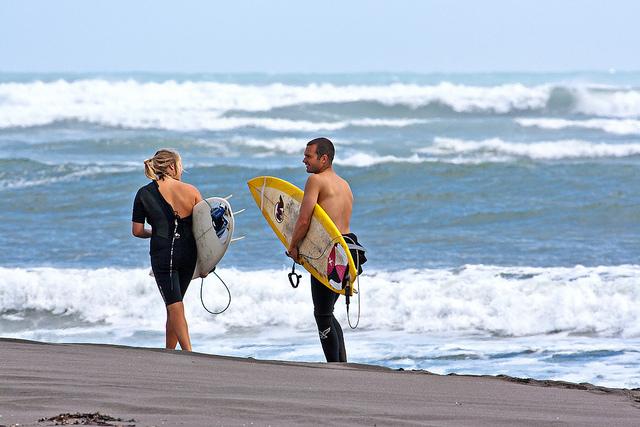Where are the sufferers?
Quick response, please. Beach. Does the water look rough?
Be succinct. Yes. What colors do the surfboards have in common?
Quick response, please. White. What is on the ground?
Be succinct. Sand. What are these people doing?
Answer briefly. Walking. What position is this woman in?
Quick response, please. Standing. What is the woman holding in her hand?
Answer briefly. Surfboard. Are they having fun?
Quick response, please. Yes. 